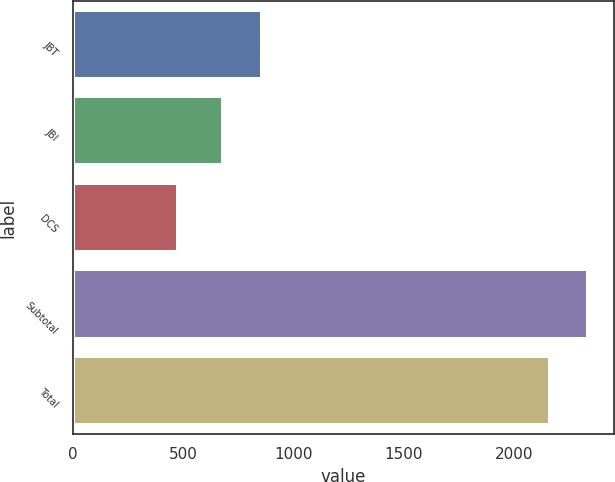<chart> <loc_0><loc_0><loc_500><loc_500><bar_chart><fcel>JBT<fcel>JBI<fcel>DCS<fcel>Subtotal<fcel>Total<nl><fcel>855.59<fcel>681.1<fcel>478.6<fcel>2334.89<fcel>2160.4<nl></chart> 